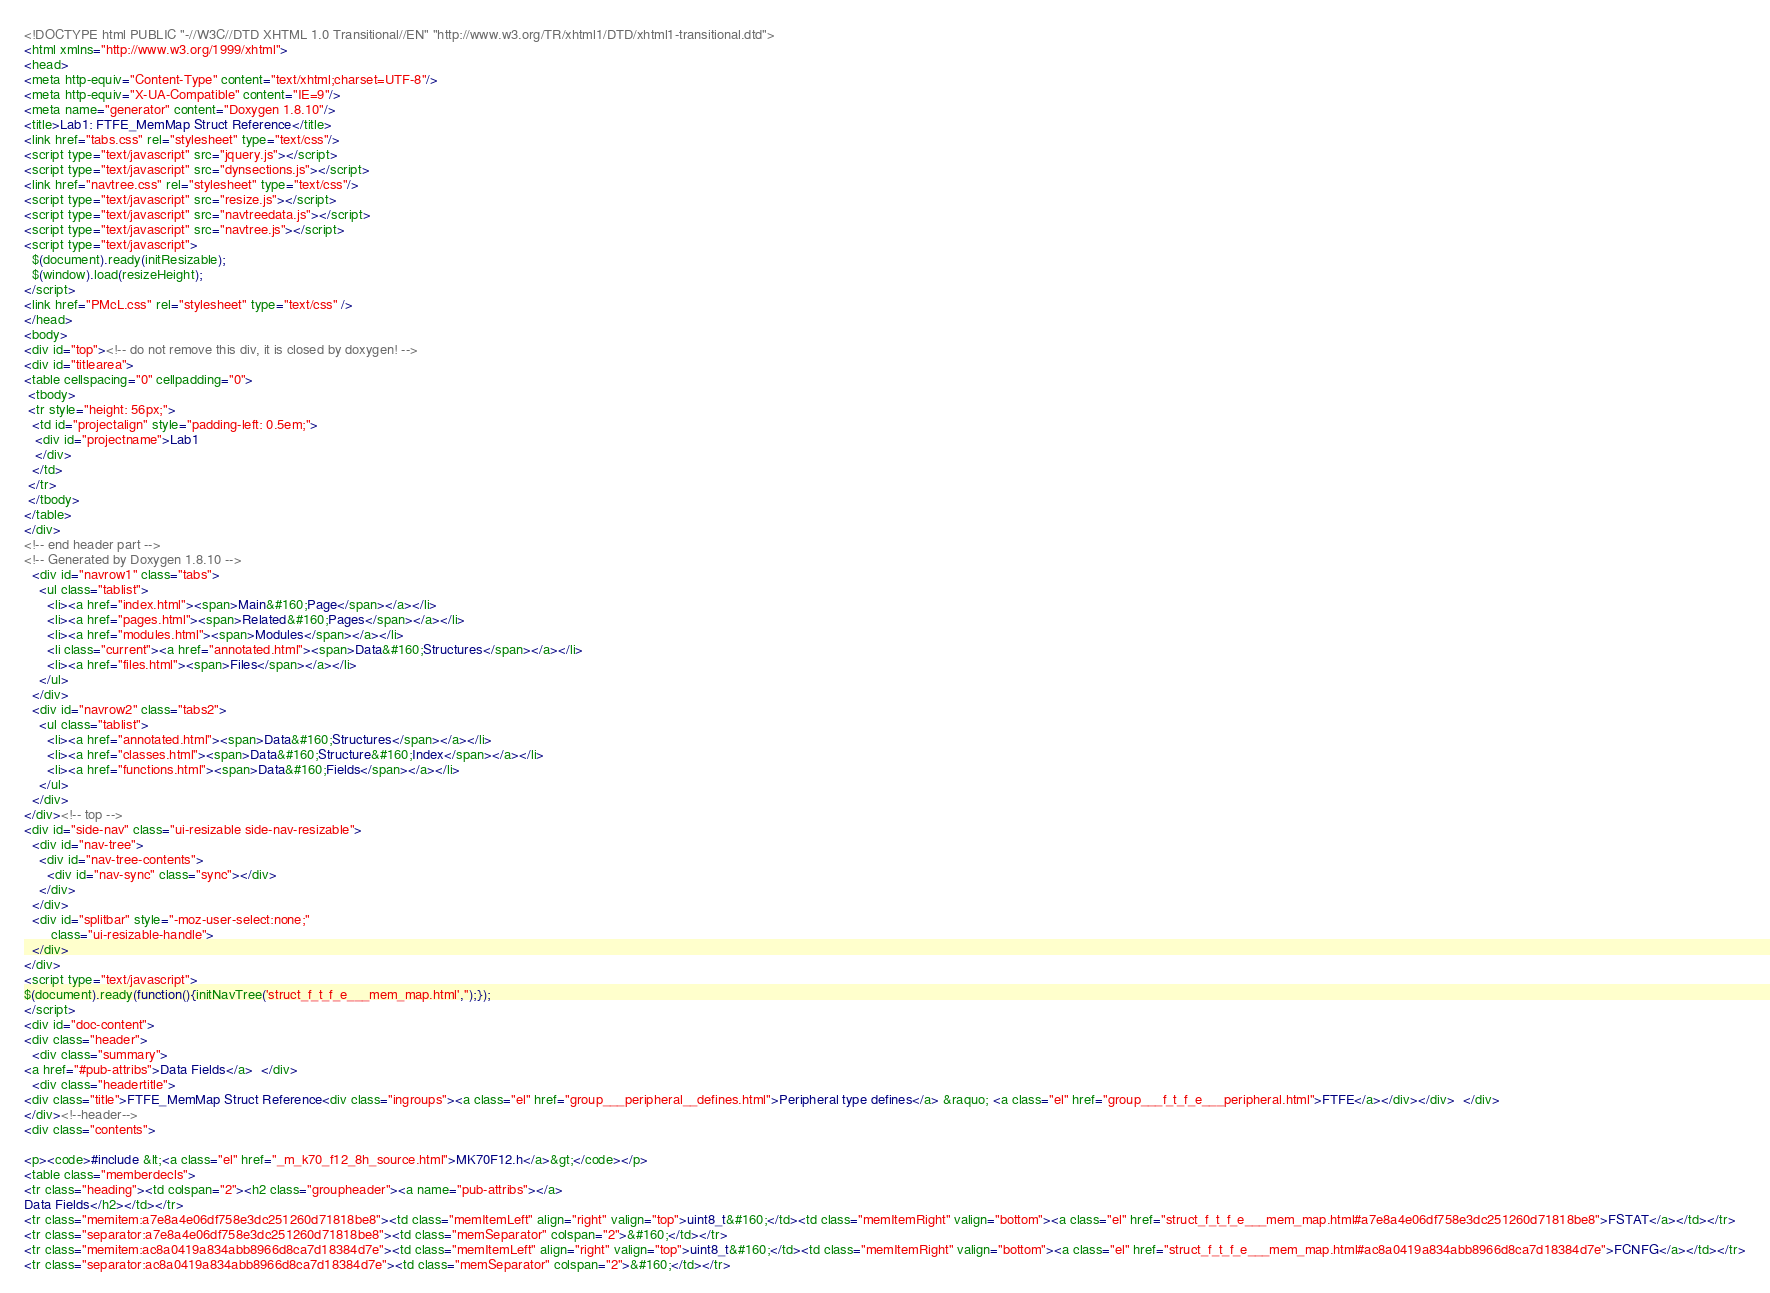<code> <loc_0><loc_0><loc_500><loc_500><_HTML_><!DOCTYPE html PUBLIC "-//W3C//DTD XHTML 1.0 Transitional//EN" "http://www.w3.org/TR/xhtml1/DTD/xhtml1-transitional.dtd">
<html xmlns="http://www.w3.org/1999/xhtml">
<head>
<meta http-equiv="Content-Type" content="text/xhtml;charset=UTF-8"/>
<meta http-equiv="X-UA-Compatible" content="IE=9"/>
<meta name="generator" content="Doxygen 1.8.10"/>
<title>Lab1: FTFE_MemMap Struct Reference</title>
<link href="tabs.css" rel="stylesheet" type="text/css"/>
<script type="text/javascript" src="jquery.js"></script>
<script type="text/javascript" src="dynsections.js"></script>
<link href="navtree.css" rel="stylesheet" type="text/css"/>
<script type="text/javascript" src="resize.js"></script>
<script type="text/javascript" src="navtreedata.js"></script>
<script type="text/javascript" src="navtree.js"></script>
<script type="text/javascript">
  $(document).ready(initResizable);
  $(window).load(resizeHeight);
</script>
<link href="PMcL.css" rel="stylesheet" type="text/css" />
</head>
<body>
<div id="top"><!-- do not remove this div, it is closed by doxygen! -->
<div id="titlearea">
<table cellspacing="0" cellpadding="0">
 <tbody>
 <tr style="height: 56px;">
  <td id="projectalign" style="padding-left: 0.5em;">
   <div id="projectname">Lab1
   </div>
  </td>
 </tr>
 </tbody>
</table>
</div>
<!-- end header part -->
<!-- Generated by Doxygen 1.8.10 -->
  <div id="navrow1" class="tabs">
    <ul class="tablist">
      <li><a href="index.html"><span>Main&#160;Page</span></a></li>
      <li><a href="pages.html"><span>Related&#160;Pages</span></a></li>
      <li><a href="modules.html"><span>Modules</span></a></li>
      <li class="current"><a href="annotated.html"><span>Data&#160;Structures</span></a></li>
      <li><a href="files.html"><span>Files</span></a></li>
    </ul>
  </div>
  <div id="navrow2" class="tabs2">
    <ul class="tablist">
      <li><a href="annotated.html"><span>Data&#160;Structures</span></a></li>
      <li><a href="classes.html"><span>Data&#160;Structure&#160;Index</span></a></li>
      <li><a href="functions.html"><span>Data&#160;Fields</span></a></li>
    </ul>
  </div>
</div><!-- top -->
<div id="side-nav" class="ui-resizable side-nav-resizable">
  <div id="nav-tree">
    <div id="nav-tree-contents">
      <div id="nav-sync" class="sync"></div>
    </div>
  </div>
  <div id="splitbar" style="-moz-user-select:none;" 
       class="ui-resizable-handle">
  </div>
</div>
<script type="text/javascript">
$(document).ready(function(){initNavTree('struct_f_t_f_e___mem_map.html','');});
</script>
<div id="doc-content">
<div class="header">
  <div class="summary">
<a href="#pub-attribs">Data Fields</a>  </div>
  <div class="headertitle">
<div class="title">FTFE_MemMap Struct Reference<div class="ingroups"><a class="el" href="group___peripheral__defines.html">Peripheral type defines</a> &raquo; <a class="el" href="group___f_t_f_e___peripheral.html">FTFE</a></div></div>  </div>
</div><!--header-->
<div class="contents">

<p><code>#include &lt;<a class="el" href="_m_k70_f12_8h_source.html">MK70F12.h</a>&gt;</code></p>
<table class="memberdecls">
<tr class="heading"><td colspan="2"><h2 class="groupheader"><a name="pub-attribs"></a>
Data Fields</h2></td></tr>
<tr class="memitem:a7e8a4e06df758e3dc251260d71818be8"><td class="memItemLeft" align="right" valign="top">uint8_t&#160;</td><td class="memItemRight" valign="bottom"><a class="el" href="struct_f_t_f_e___mem_map.html#a7e8a4e06df758e3dc251260d71818be8">FSTAT</a></td></tr>
<tr class="separator:a7e8a4e06df758e3dc251260d71818be8"><td class="memSeparator" colspan="2">&#160;</td></tr>
<tr class="memitem:ac8a0419a834abb8966d8ca7d18384d7e"><td class="memItemLeft" align="right" valign="top">uint8_t&#160;</td><td class="memItemRight" valign="bottom"><a class="el" href="struct_f_t_f_e___mem_map.html#ac8a0419a834abb8966d8ca7d18384d7e">FCNFG</a></td></tr>
<tr class="separator:ac8a0419a834abb8966d8ca7d18384d7e"><td class="memSeparator" colspan="2">&#160;</td></tr></code> 